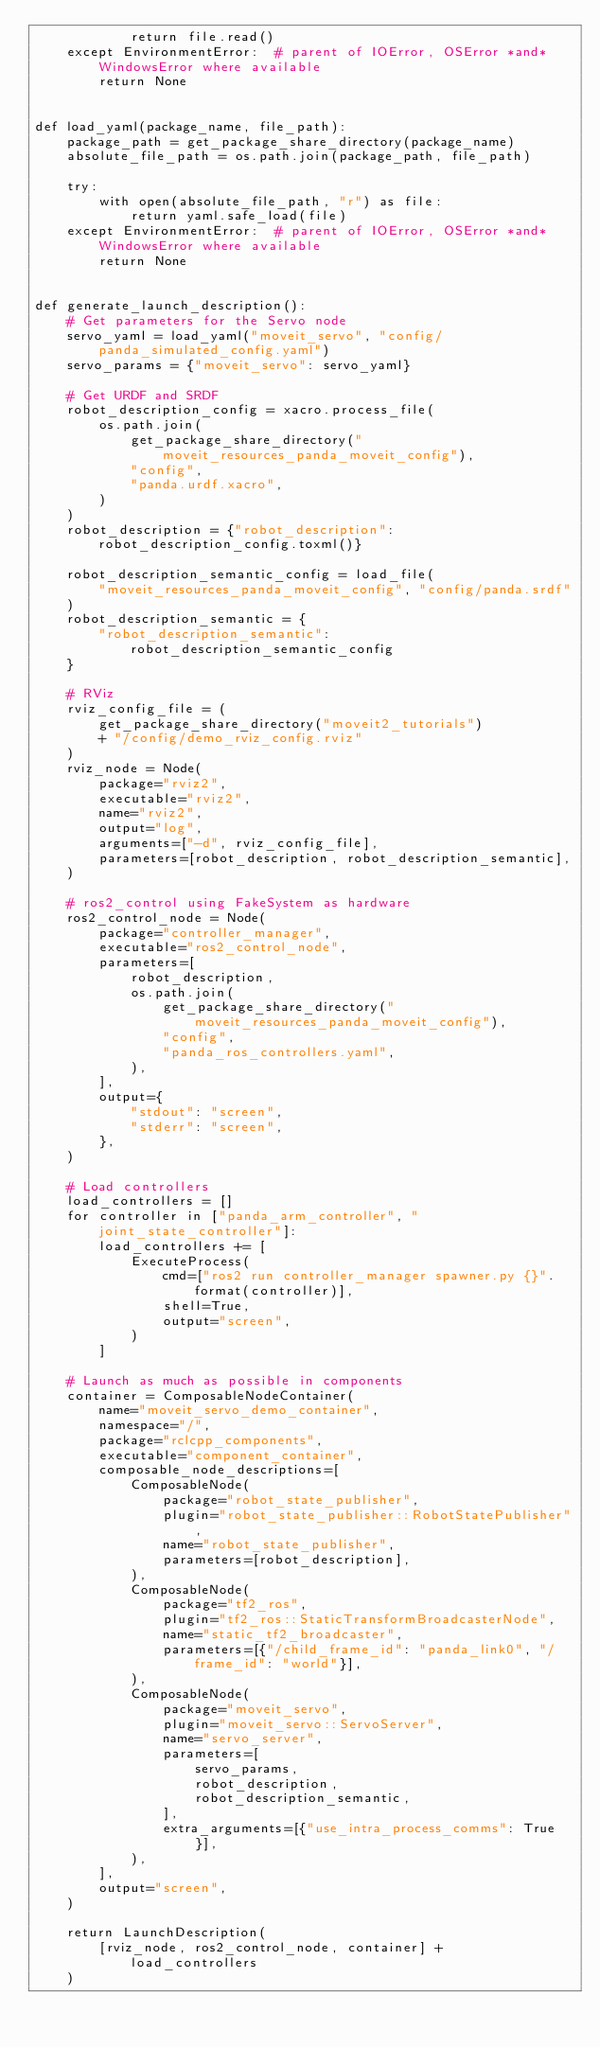<code> <loc_0><loc_0><loc_500><loc_500><_Python_>            return file.read()
    except EnvironmentError:  # parent of IOError, OSError *and* WindowsError where available
        return None


def load_yaml(package_name, file_path):
    package_path = get_package_share_directory(package_name)
    absolute_file_path = os.path.join(package_path, file_path)

    try:
        with open(absolute_file_path, "r") as file:
            return yaml.safe_load(file)
    except EnvironmentError:  # parent of IOError, OSError *and* WindowsError where available
        return None


def generate_launch_description():
    # Get parameters for the Servo node
    servo_yaml = load_yaml("moveit_servo", "config/panda_simulated_config.yaml")
    servo_params = {"moveit_servo": servo_yaml}

    # Get URDF and SRDF
    robot_description_config = xacro.process_file(
        os.path.join(
            get_package_share_directory("moveit_resources_panda_moveit_config"),
            "config",
            "panda.urdf.xacro",
        )
    )
    robot_description = {"robot_description": robot_description_config.toxml()}

    robot_description_semantic_config = load_file(
        "moveit_resources_panda_moveit_config", "config/panda.srdf"
    )
    robot_description_semantic = {
        "robot_description_semantic": robot_description_semantic_config
    }

    # RViz
    rviz_config_file = (
        get_package_share_directory("moveit2_tutorials")
        + "/config/demo_rviz_config.rviz"
    )
    rviz_node = Node(
        package="rviz2",
        executable="rviz2",
        name="rviz2",
        output="log",
        arguments=["-d", rviz_config_file],
        parameters=[robot_description, robot_description_semantic],
    )

    # ros2_control using FakeSystem as hardware
    ros2_control_node = Node(
        package="controller_manager",
        executable="ros2_control_node",
        parameters=[
            robot_description,
            os.path.join(
                get_package_share_directory("moveit_resources_panda_moveit_config"),
                "config",
                "panda_ros_controllers.yaml",
            ),
        ],
        output={
            "stdout": "screen",
            "stderr": "screen",
        },
    )

    # Load controllers
    load_controllers = []
    for controller in ["panda_arm_controller", "joint_state_controller"]:
        load_controllers += [
            ExecuteProcess(
                cmd=["ros2 run controller_manager spawner.py {}".format(controller)],
                shell=True,
                output="screen",
            )
        ]

    # Launch as much as possible in components
    container = ComposableNodeContainer(
        name="moveit_servo_demo_container",
        namespace="/",
        package="rclcpp_components",
        executable="component_container",
        composable_node_descriptions=[
            ComposableNode(
                package="robot_state_publisher",
                plugin="robot_state_publisher::RobotStatePublisher",
                name="robot_state_publisher",
                parameters=[robot_description],
            ),
            ComposableNode(
                package="tf2_ros",
                plugin="tf2_ros::StaticTransformBroadcasterNode",
                name="static_tf2_broadcaster",
                parameters=[{"/child_frame_id": "panda_link0", "/frame_id": "world"}],
            ),
            ComposableNode(
                package="moveit_servo",
                plugin="moveit_servo::ServoServer",
                name="servo_server",
                parameters=[
                    servo_params,
                    robot_description,
                    robot_description_semantic,
                ],
                extra_arguments=[{"use_intra_process_comms": True}],
            ),
        ],
        output="screen",
    )

    return LaunchDescription(
        [rviz_node, ros2_control_node, container] + load_controllers
    )
</code> 